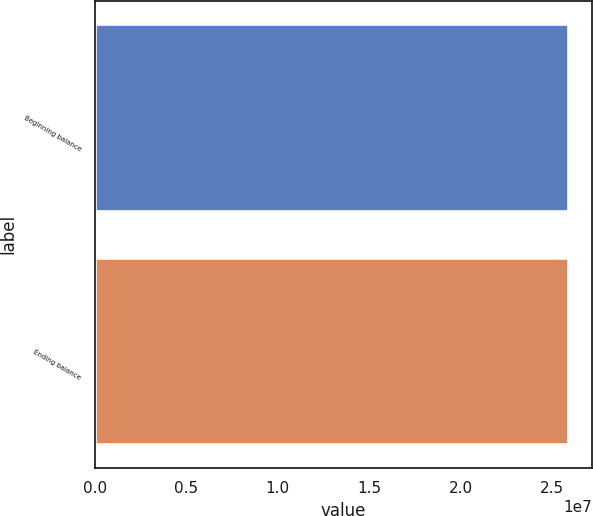Convert chart. <chart><loc_0><loc_0><loc_500><loc_500><bar_chart><fcel>Beginning balance<fcel>Ending balance<nl><fcel>2.5875e+07<fcel>2.5875e+07<nl></chart> 